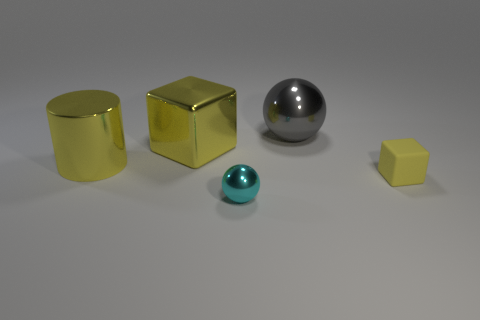Do the gray object and the ball in front of the yellow rubber object have the same size?
Ensure brevity in your answer.  No. What is the material of the small thing in front of the yellow rubber object?
Provide a short and direct response. Metal. There is a ball that is in front of the small matte thing; what number of yellow metallic cylinders are right of it?
Ensure brevity in your answer.  0. Are there any large green metal objects that have the same shape as the cyan thing?
Provide a succinct answer. No. There is a block on the left side of the small rubber cube; is its size the same as the ball in front of the yellow rubber thing?
Your answer should be compact. No. The object to the left of the yellow block that is left of the tiny cyan metallic object is what shape?
Keep it short and to the point. Cylinder. What number of cubes are the same size as the cyan shiny ball?
Your answer should be very brief. 1. Are any large gray cylinders visible?
Provide a short and direct response. No. Is there anything else that is the same color as the small metal ball?
Your answer should be very brief. No. There is a small cyan thing that is made of the same material as the large gray object; what is its shape?
Your response must be concise. Sphere. 